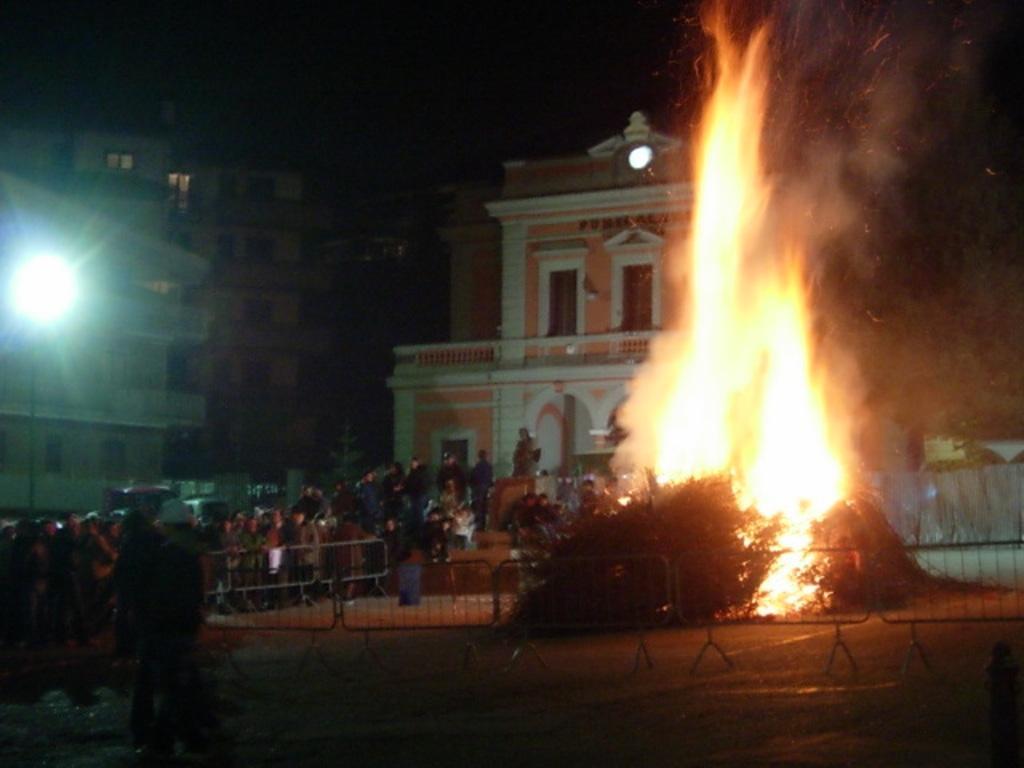Could you give a brief overview of what you see in this image? In this image we can see people, fence, fire, pole, light, and buildings. There is a dark background. 